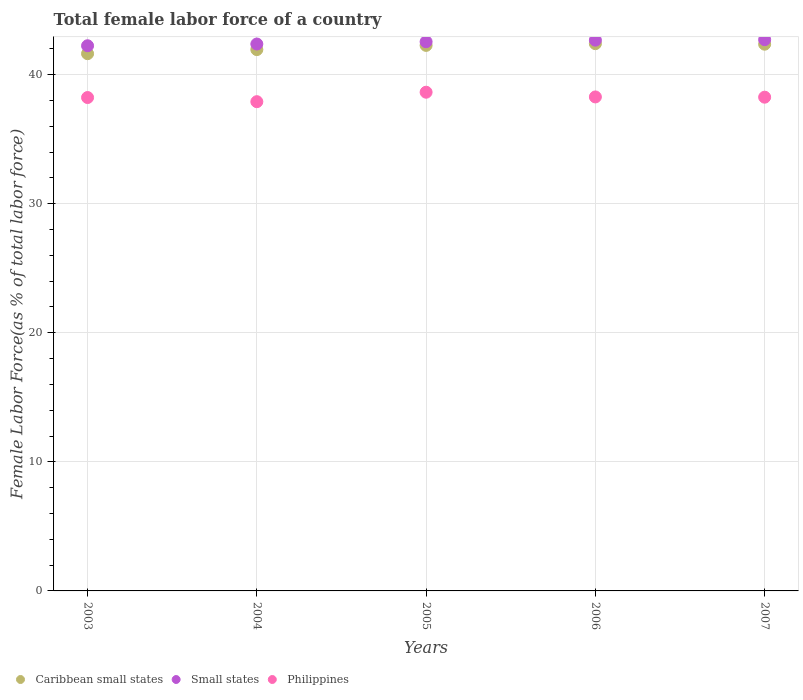What is the percentage of female labor force in Caribbean small states in 2004?
Offer a terse response. 41.95. Across all years, what is the maximum percentage of female labor force in Caribbean small states?
Make the answer very short. 42.4. Across all years, what is the minimum percentage of female labor force in Caribbean small states?
Keep it short and to the point. 41.63. In which year was the percentage of female labor force in Caribbean small states minimum?
Keep it short and to the point. 2003. What is the total percentage of female labor force in Caribbean small states in the graph?
Provide a short and direct response. 210.62. What is the difference between the percentage of female labor force in Small states in 2004 and that in 2006?
Your response must be concise. -0.3. What is the difference between the percentage of female labor force in Philippines in 2006 and the percentage of female labor force in Small states in 2004?
Provide a succinct answer. -4.1. What is the average percentage of female labor force in Small states per year?
Offer a very short reply. 42.51. In the year 2003, what is the difference between the percentage of female labor force in Caribbean small states and percentage of female labor force in Small states?
Your response must be concise. -0.61. In how many years, is the percentage of female labor force in Philippines greater than 36 %?
Offer a terse response. 5. What is the ratio of the percentage of female labor force in Small states in 2003 to that in 2004?
Provide a short and direct response. 1. Is the percentage of female labor force in Philippines in 2003 less than that in 2005?
Provide a short and direct response. Yes. Is the difference between the percentage of female labor force in Caribbean small states in 2004 and 2005 greater than the difference between the percentage of female labor force in Small states in 2004 and 2005?
Offer a very short reply. No. What is the difference between the highest and the second highest percentage of female labor force in Philippines?
Ensure brevity in your answer.  0.37. What is the difference between the highest and the lowest percentage of female labor force in Caribbean small states?
Offer a very short reply. 0.78. In how many years, is the percentage of female labor force in Small states greater than the average percentage of female labor force in Small states taken over all years?
Make the answer very short. 3. Is the sum of the percentage of female labor force in Philippines in 2003 and 2004 greater than the maximum percentage of female labor force in Caribbean small states across all years?
Provide a succinct answer. Yes. Is it the case that in every year, the sum of the percentage of female labor force in Philippines and percentage of female labor force in Caribbean small states  is greater than the percentage of female labor force in Small states?
Keep it short and to the point. Yes. How many dotlines are there?
Offer a very short reply. 3. How many years are there in the graph?
Your response must be concise. 5. Does the graph contain any zero values?
Your response must be concise. No. Does the graph contain grids?
Give a very brief answer. Yes. Where does the legend appear in the graph?
Your answer should be compact. Bottom left. How are the legend labels stacked?
Your answer should be very brief. Horizontal. What is the title of the graph?
Ensure brevity in your answer.  Total female labor force of a country. Does "Lesotho" appear as one of the legend labels in the graph?
Ensure brevity in your answer.  No. What is the label or title of the Y-axis?
Keep it short and to the point. Female Labor Force(as % of total labor force). What is the Female Labor Force(as % of total labor force) of Caribbean small states in 2003?
Give a very brief answer. 41.63. What is the Female Labor Force(as % of total labor force) of Small states in 2003?
Offer a terse response. 42.24. What is the Female Labor Force(as % of total labor force) of Philippines in 2003?
Offer a terse response. 38.23. What is the Female Labor Force(as % of total labor force) of Caribbean small states in 2004?
Keep it short and to the point. 41.95. What is the Female Labor Force(as % of total labor force) of Small states in 2004?
Ensure brevity in your answer.  42.38. What is the Female Labor Force(as % of total labor force) of Philippines in 2004?
Offer a very short reply. 37.91. What is the Female Labor Force(as % of total labor force) in Caribbean small states in 2005?
Your answer should be compact. 42.27. What is the Female Labor Force(as % of total labor force) in Small states in 2005?
Offer a terse response. 42.55. What is the Female Labor Force(as % of total labor force) of Philippines in 2005?
Your answer should be compact. 38.64. What is the Female Labor Force(as % of total labor force) of Caribbean small states in 2006?
Provide a succinct answer. 42.4. What is the Female Labor Force(as % of total labor force) in Small states in 2006?
Keep it short and to the point. 42.68. What is the Female Labor Force(as % of total labor force) of Philippines in 2006?
Your answer should be very brief. 38.28. What is the Female Labor Force(as % of total labor force) of Caribbean small states in 2007?
Provide a short and direct response. 42.36. What is the Female Labor Force(as % of total labor force) of Small states in 2007?
Your response must be concise. 42.71. What is the Female Labor Force(as % of total labor force) of Philippines in 2007?
Offer a terse response. 38.26. Across all years, what is the maximum Female Labor Force(as % of total labor force) of Caribbean small states?
Provide a short and direct response. 42.4. Across all years, what is the maximum Female Labor Force(as % of total labor force) of Small states?
Offer a very short reply. 42.71. Across all years, what is the maximum Female Labor Force(as % of total labor force) of Philippines?
Keep it short and to the point. 38.64. Across all years, what is the minimum Female Labor Force(as % of total labor force) in Caribbean small states?
Offer a terse response. 41.63. Across all years, what is the minimum Female Labor Force(as % of total labor force) of Small states?
Your response must be concise. 42.24. Across all years, what is the minimum Female Labor Force(as % of total labor force) in Philippines?
Ensure brevity in your answer.  37.91. What is the total Female Labor Force(as % of total labor force) of Caribbean small states in the graph?
Provide a short and direct response. 210.62. What is the total Female Labor Force(as % of total labor force) of Small states in the graph?
Your answer should be compact. 212.57. What is the total Female Labor Force(as % of total labor force) in Philippines in the graph?
Your response must be concise. 191.32. What is the difference between the Female Labor Force(as % of total labor force) of Caribbean small states in 2003 and that in 2004?
Provide a succinct answer. -0.32. What is the difference between the Female Labor Force(as % of total labor force) in Small states in 2003 and that in 2004?
Keep it short and to the point. -0.13. What is the difference between the Female Labor Force(as % of total labor force) of Philippines in 2003 and that in 2004?
Make the answer very short. 0.32. What is the difference between the Female Labor Force(as % of total labor force) of Caribbean small states in 2003 and that in 2005?
Provide a succinct answer. -0.64. What is the difference between the Female Labor Force(as % of total labor force) in Small states in 2003 and that in 2005?
Offer a very short reply. -0.31. What is the difference between the Female Labor Force(as % of total labor force) of Philippines in 2003 and that in 2005?
Provide a succinct answer. -0.41. What is the difference between the Female Labor Force(as % of total labor force) in Caribbean small states in 2003 and that in 2006?
Keep it short and to the point. -0.78. What is the difference between the Female Labor Force(as % of total labor force) of Small states in 2003 and that in 2006?
Your answer should be very brief. -0.43. What is the difference between the Female Labor Force(as % of total labor force) in Philippines in 2003 and that in 2006?
Your response must be concise. -0.05. What is the difference between the Female Labor Force(as % of total labor force) in Caribbean small states in 2003 and that in 2007?
Offer a terse response. -0.74. What is the difference between the Female Labor Force(as % of total labor force) of Small states in 2003 and that in 2007?
Ensure brevity in your answer.  -0.47. What is the difference between the Female Labor Force(as % of total labor force) of Philippines in 2003 and that in 2007?
Keep it short and to the point. -0.03. What is the difference between the Female Labor Force(as % of total labor force) of Caribbean small states in 2004 and that in 2005?
Ensure brevity in your answer.  -0.33. What is the difference between the Female Labor Force(as % of total labor force) of Small states in 2004 and that in 2005?
Make the answer very short. -0.18. What is the difference between the Female Labor Force(as % of total labor force) of Philippines in 2004 and that in 2005?
Ensure brevity in your answer.  -0.73. What is the difference between the Female Labor Force(as % of total labor force) in Caribbean small states in 2004 and that in 2006?
Provide a succinct answer. -0.46. What is the difference between the Female Labor Force(as % of total labor force) in Small states in 2004 and that in 2006?
Make the answer very short. -0.3. What is the difference between the Female Labor Force(as % of total labor force) in Philippines in 2004 and that in 2006?
Give a very brief answer. -0.37. What is the difference between the Female Labor Force(as % of total labor force) in Caribbean small states in 2004 and that in 2007?
Offer a very short reply. -0.42. What is the difference between the Female Labor Force(as % of total labor force) of Small states in 2004 and that in 2007?
Provide a succinct answer. -0.34. What is the difference between the Female Labor Force(as % of total labor force) in Philippines in 2004 and that in 2007?
Ensure brevity in your answer.  -0.35. What is the difference between the Female Labor Force(as % of total labor force) of Caribbean small states in 2005 and that in 2006?
Keep it short and to the point. -0.13. What is the difference between the Female Labor Force(as % of total labor force) of Small states in 2005 and that in 2006?
Your response must be concise. -0.12. What is the difference between the Female Labor Force(as % of total labor force) of Philippines in 2005 and that in 2006?
Keep it short and to the point. 0.37. What is the difference between the Female Labor Force(as % of total labor force) of Caribbean small states in 2005 and that in 2007?
Keep it short and to the point. -0.09. What is the difference between the Female Labor Force(as % of total labor force) of Small states in 2005 and that in 2007?
Your answer should be compact. -0.16. What is the difference between the Female Labor Force(as % of total labor force) of Philippines in 2005 and that in 2007?
Your answer should be very brief. 0.38. What is the difference between the Female Labor Force(as % of total labor force) in Caribbean small states in 2006 and that in 2007?
Offer a terse response. 0.04. What is the difference between the Female Labor Force(as % of total labor force) in Small states in 2006 and that in 2007?
Provide a succinct answer. -0.04. What is the difference between the Female Labor Force(as % of total labor force) of Philippines in 2006 and that in 2007?
Your response must be concise. 0.02. What is the difference between the Female Labor Force(as % of total labor force) of Caribbean small states in 2003 and the Female Labor Force(as % of total labor force) of Small states in 2004?
Your response must be concise. -0.75. What is the difference between the Female Labor Force(as % of total labor force) in Caribbean small states in 2003 and the Female Labor Force(as % of total labor force) in Philippines in 2004?
Give a very brief answer. 3.72. What is the difference between the Female Labor Force(as % of total labor force) of Small states in 2003 and the Female Labor Force(as % of total labor force) of Philippines in 2004?
Ensure brevity in your answer.  4.33. What is the difference between the Female Labor Force(as % of total labor force) in Caribbean small states in 2003 and the Female Labor Force(as % of total labor force) in Small states in 2005?
Offer a terse response. -0.92. What is the difference between the Female Labor Force(as % of total labor force) of Caribbean small states in 2003 and the Female Labor Force(as % of total labor force) of Philippines in 2005?
Offer a terse response. 2.99. What is the difference between the Female Labor Force(as % of total labor force) in Small states in 2003 and the Female Labor Force(as % of total labor force) in Philippines in 2005?
Keep it short and to the point. 3.6. What is the difference between the Female Labor Force(as % of total labor force) in Caribbean small states in 2003 and the Female Labor Force(as % of total labor force) in Small states in 2006?
Offer a very short reply. -1.05. What is the difference between the Female Labor Force(as % of total labor force) in Caribbean small states in 2003 and the Female Labor Force(as % of total labor force) in Philippines in 2006?
Provide a short and direct response. 3.35. What is the difference between the Female Labor Force(as % of total labor force) of Small states in 2003 and the Female Labor Force(as % of total labor force) of Philippines in 2006?
Your response must be concise. 3.97. What is the difference between the Female Labor Force(as % of total labor force) of Caribbean small states in 2003 and the Female Labor Force(as % of total labor force) of Small states in 2007?
Offer a terse response. -1.08. What is the difference between the Female Labor Force(as % of total labor force) in Caribbean small states in 2003 and the Female Labor Force(as % of total labor force) in Philippines in 2007?
Offer a terse response. 3.37. What is the difference between the Female Labor Force(as % of total labor force) of Small states in 2003 and the Female Labor Force(as % of total labor force) of Philippines in 2007?
Offer a terse response. 3.99. What is the difference between the Female Labor Force(as % of total labor force) of Caribbean small states in 2004 and the Female Labor Force(as % of total labor force) of Small states in 2005?
Offer a terse response. -0.61. What is the difference between the Female Labor Force(as % of total labor force) of Caribbean small states in 2004 and the Female Labor Force(as % of total labor force) of Philippines in 2005?
Offer a terse response. 3.3. What is the difference between the Female Labor Force(as % of total labor force) in Small states in 2004 and the Female Labor Force(as % of total labor force) in Philippines in 2005?
Keep it short and to the point. 3.73. What is the difference between the Female Labor Force(as % of total labor force) in Caribbean small states in 2004 and the Female Labor Force(as % of total labor force) in Small states in 2006?
Offer a very short reply. -0.73. What is the difference between the Female Labor Force(as % of total labor force) in Caribbean small states in 2004 and the Female Labor Force(as % of total labor force) in Philippines in 2006?
Your response must be concise. 3.67. What is the difference between the Female Labor Force(as % of total labor force) in Caribbean small states in 2004 and the Female Labor Force(as % of total labor force) in Small states in 2007?
Provide a short and direct response. -0.77. What is the difference between the Female Labor Force(as % of total labor force) of Caribbean small states in 2004 and the Female Labor Force(as % of total labor force) of Philippines in 2007?
Make the answer very short. 3.69. What is the difference between the Female Labor Force(as % of total labor force) of Small states in 2004 and the Female Labor Force(as % of total labor force) of Philippines in 2007?
Your answer should be compact. 4.12. What is the difference between the Female Labor Force(as % of total labor force) in Caribbean small states in 2005 and the Female Labor Force(as % of total labor force) in Small states in 2006?
Offer a very short reply. -0.41. What is the difference between the Female Labor Force(as % of total labor force) of Caribbean small states in 2005 and the Female Labor Force(as % of total labor force) of Philippines in 2006?
Your answer should be compact. 3.99. What is the difference between the Female Labor Force(as % of total labor force) in Small states in 2005 and the Female Labor Force(as % of total labor force) in Philippines in 2006?
Provide a short and direct response. 4.28. What is the difference between the Female Labor Force(as % of total labor force) in Caribbean small states in 2005 and the Female Labor Force(as % of total labor force) in Small states in 2007?
Give a very brief answer. -0.44. What is the difference between the Female Labor Force(as % of total labor force) in Caribbean small states in 2005 and the Female Labor Force(as % of total labor force) in Philippines in 2007?
Your answer should be compact. 4.01. What is the difference between the Female Labor Force(as % of total labor force) of Small states in 2005 and the Female Labor Force(as % of total labor force) of Philippines in 2007?
Provide a short and direct response. 4.3. What is the difference between the Female Labor Force(as % of total labor force) of Caribbean small states in 2006 and the Female Labor Force(as % of total labor force) of Small states in 2007?
Make the answer very short. -0.31. What is the difference between the Female Labor Force(as % of total labor force) in Caribbean small states in 2006 and the Female Labor Force(as % of total labor force) in Philippines in 2007?
Give a very brief answer. 4.15. What is the difference between the Female Labor Force(as % of total labor force) of Small states in 2006 and the Female Labor Force(as % of total labor force) of Philippines in 2007?
Your answer should be compact. 4.42. What is the average Female Labor Force(as % of total labor force) of Caribbean small states per year?
Your response must be concise. 42.12. What is the average Female Labor Force(as % of total labor force) of Small states per year?
Your answer should be very brief. 42.51. What is the average Female Labor Force(as % of total labor force) in Philippines per year?
Your answer should be very brief. 38.26. In the year 2003, what is the difference between the Female Labor Force(as % of total labor force) of Caribbean small states and Female Labor Force(as % of total labor force) of Small states?
Give a very brief answer. -0.61. In the year 2003, what is the difference between the Female Labor Force(as % of total labor force) in Caribbean small states and Female Labor Force(as % of total labor force) in Philippines?
Your answer should be compact. 3.4. In the year 2003, what is the difference between the Female Labor Force(as % of total labor force) in Small states and Female Labor Force(as % of total labor force) in Philippines?
Your response must be concise. 4.01. In the year 2004, what is the difference between the Female Labor Force(as % of total labor force) of Caribbean small states and Female Labor Force(as % of total labor force) of Small states?
Offer a terse response. -0.43. In the year 2004, what is the difference between the Female Labor Force(as % of total labor force) in Caribbean small states and Female Labor Force(as % of total labor force) in Philippines?
Offer a very short reply. 4.04. In the year 2004, what is the difference between the Female Labor Force(as % of total labor force) of Small states and Female Labor Force(as % of total labor force) of Philippines?
Your response must be concise. 4.47. In the year 2005, what is the difference between the Female Labor Force(as % of total labor force) of Caribbean small states and Female Labor Force(as % of total labor force) of Small states?
Keep it short and to the point. -0.28. In the year 2005, what is the difference between the Female Labor Force(as % of total labor force) in Caribbean small states and Female Labor Force(as % of total labor force) in Philippines?
Your response must be concise. 3.63. In the year 2005, what is the difference between the Female Labor Force(as % of total labor force) of Small states and Female Labor Force(as % of total labor force) of Philippines?
Give a very brief answer. 3.91. In the year 2006, what is the difference between the Female Labor Force(as % of total labor force) in Caribbean small states and Female Labor Force(as % of total labor force) in Small states?
Your answer should be compact. -0.27. In the year 2006, what is the difference between the Female Labor Force(as % of total labor force) in Caribbean small states and Female Labor Force(as % of total labor force) in Philippines?
Offer a very short reply. 4.13. In the year 2006, what is the difference between the Female Labor Force(as % of total labor force) of Small states and Female Labor Force(as % of total labor force) of Philippines?
Offer a very short reply. 4.4. In the year 2007, what is the difference between the Female Labor Force(as % of total labor force) of Caribbean small states and Female Labor Force(as % of total labor force) of Small states?
Ensure brevity in your answer.  -0.35. In the year 2007, what is the difference between the Female Labor Force(as % of total labor force) of Caribbean small states and Female Labor Force(as % of total labor force) of Philippines?
Make the answer very short. 4.11. In the year 2007, what is the difference between the Female Labor Force(as % of total labor force) in Small states and Female Labor Force(as % of total labor force) in Philippines?
Provide a short and direct response. 4.46. What is the ratio of the Female Labor Force(as % of total labor force) of Small states in 2003 to that in 2004?
Your answer should be very brief. 1. What is the ratio of the Female Labor Force(as % of total labor force) of Philippines in 2003 to that in 2004?
Your answer should be very brief. 1.01. What is the ratio of the Female Labor Force(as % of total labor force) in Small states in 2003 to that in 2005?
Make the answer very short. 0.99. What is the ratio of the Female Labor Force(as % of total labor force) in Philippines in 2003 to that in 2005?
Your answer should be very brief. 0.99. What is the ratio of the Female Labor Force(as % of total labor force) of Caribbean small states in 2003 to that in 2006?
Offer a terse response. 0.98. What is the ratio of the Female Labor Force(as % of total labor force) in Philippines in 2003 to that in 2006?
Provide a succinct answer. 1. What is the ratio of the Female Labor Force(as % of total labor force) of Caribbean small states in 2003 to that in 2007?
Provide a short and direct response. 0.98. What is the ratio of the Female Labor Force(as % of total labor force) in Philippines in 2003 to that in 2007?
Make the answer very short. 1. What is the ratio of the Female Labor Force(as % of total labor force) in Caribbean small states in 2004 to that in 2005?
Make the answer very short. 0.99. What is the ratio of the Female Labor Force(as % of total labor force) in Small states in 2004 to that in 2005?
Give a very brief answer. 1. What is the ratio of the Female Labor Force(as % of total labor force) of Philippines in 2004 to that in 2005?
Your response must be concise. 0.98. What is the ratio of the Female Labor Force(as % of total labor force) of Caribbean small states in 2004 to that in 2006?
Ensure brevity in your answer.  0.99. What is the ratio of the Female Labor Force(as % of total labor force) of Philippines in 2004 to that in 2006?
Ensure brevity in your answer.  0.99. What is the ratio of the Female Labor Force(as % of total labor force) of Philippines in 2004 to that in 2007?
Offer a terse response. 0.99. What is the ratio of the Female Labor Force(as % of total labor force) in Small states in 2005 to that in 2006?
Offer a very short reply. 1. What is the ratio of the Female Labor Force(as % of total labor force) of Philippines in 2005 to that in 2006?
Make the answer very short. 1.01. What is the ratio of the Female Labor Force(as % of total labor force) of Caribbean small states in 2005 to that in 2007?
Offer a very short reply. 1. What is the ratio of the Female Labor Force(as % of total labor force) in Caribbean small states in 2006 to that in 2007?
Offer a terse response. 1. What is the difference between the highest and the second highest Female Labor Force(as % of total labor force) of Caribbean small states?
Your answer should be very brief. 0.04. What is the difference between the highest and the second highest Female Labor Force(as % of total labor force) in Small states?
Ensure brevity in your answer.  0.04. What is the difference between the highest and the second highest Female Labor Force(as % of total labor force) in Philippines?
Give a very brief answer. 0.37. What is the difference between the highest and the lowest Female Labor Force(as % of total labor force) in Caribbean small states?
Your response must be concise. 0.78. What is the difference between the highest and the lowest Female Labor Force(as % of total labor force) in Small states?
Your answer should be compact. 0.47. What is the difference between the highest and the lowest Female Labor Force(as % of total labor force) of Philippines?
Offer a very short reply. 0.73. 